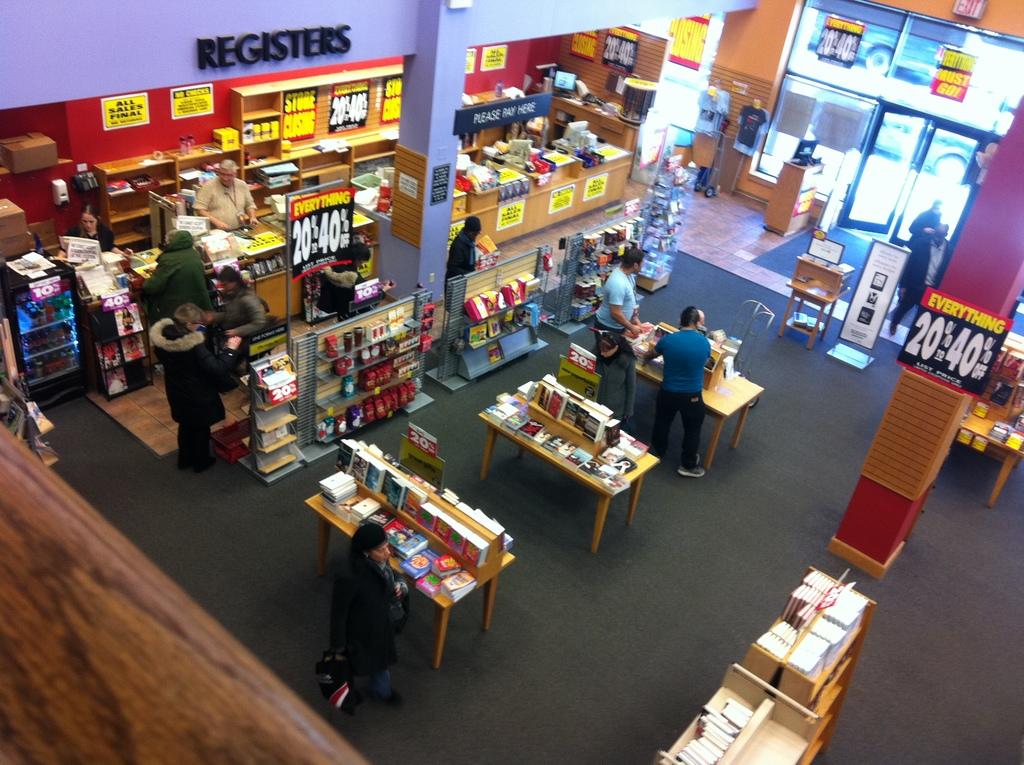What sign is written in black letters on the purple wall?
Provide a succinct answer. Registers. 